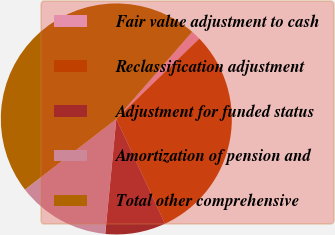Convert chart to OTSL. <chart><loc_0><loc_0><loc_500><loc_500><pie_chart><fcel>Fair value adjustment to cash<fcel>Reclassification adjustment<fcel>Adjustment for funded status<fcel>Amortization of pension and<fcel>Total other comprehensive<nl><fcel>1.36%<fcel>30.32%<fcel>8.45%<fcel>13.0%<fcel>46.87%<nl></chart> 